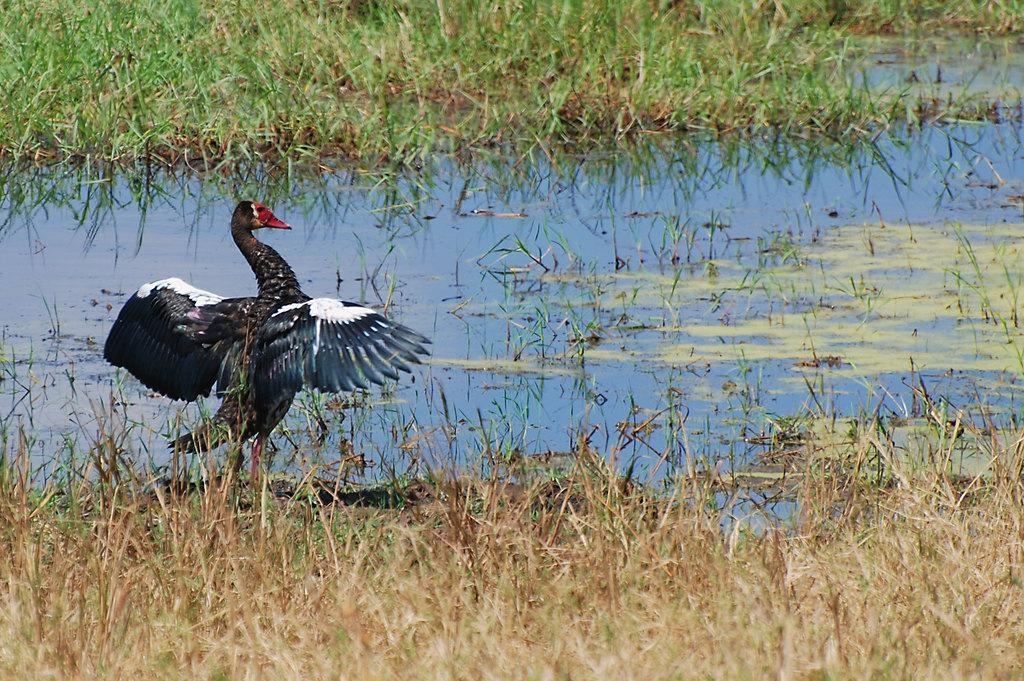What type of vegetation is at the bottom of the image? There is grass at the bottom of the image. What is located in the middle of the image? There is water in the middle of the image. What bird can be seen on the left side of the image? There is a cormorant on the left side of the image. What type of honey is being collected by the cormorant in the image? There is no honey present in the image, and the cormorant is not collecting anything. What act is the cormorant performing in the image? The cormorant is simply perched on the left side of the image, and no specific act can be identified. 